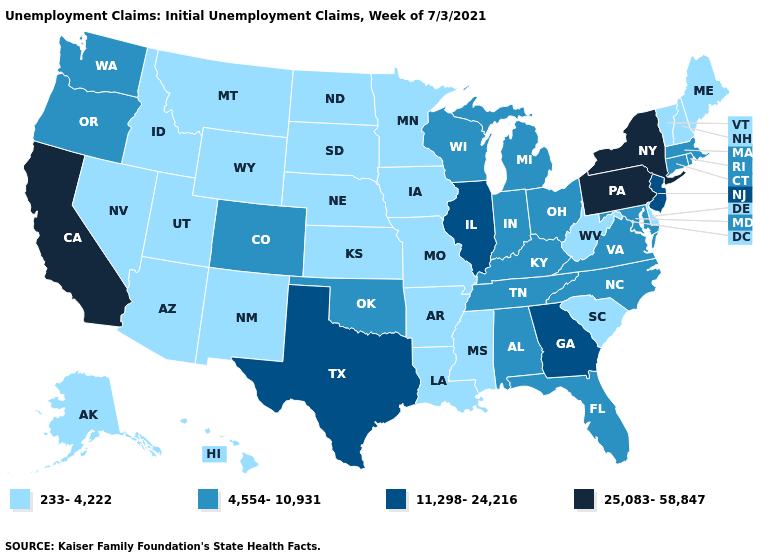Does Mississippi have the lowest value in the USA?
Be succinct. Yes. What is the lowest value in the USA?
Write a very short answer. 233-4,222. Which states hav the highest value in the MidWest?
Write a very short answer. Illinois. Does Illinois have the lowest value in the MidWest?
Write a very short answer. No. Does the first symbol in the legend represent the smallest category?
Concise answer only. Yes. Among the states that border Arkansas , does Oklahoma have the lowest value?
Write a very short answer. No. Does the first symbol in the legend represent the smallest category?
Concise answer only. Yes. How many symbols are there in the legend?
Concise answer only. 4. What is the value of Connecticut?
Answer briefly. 4,554-10,931. Name the states that have a value in the range 11,298-24,216?
Write a very short answer. Georgia, Illinois, New Jersey, Texas. What is the lowest value in the USA?
Concise answer only. 233-4,222. Among the states that border Arkansas , does Mississippi have the highest value?
Write a very short answer. No. Does the first symbol in the legend represent the smallest category?
Give a very brief answer. Yes. What is the lowest value in states that border Idaho?
Write a very short answer. 233-4,222. What is the lowest value in states that border Kentucky?
Keep it brief. 233-4,222. 